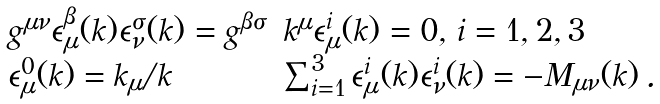<formula> <loc_0><loc_0><loc_500><loc_500>\begin{array} { l l } g ^ { \mu \nu } \epsilon _ { \mu } ^ { \beta } ( k ) \epsilon _ { \nu } ^ { \sigma } ( k ) = g ^ { \beta \sigma } & k ^ { \mu } \epsilon _ { \mu } ^ { i } ( k ) = 0 , \, i = 1 , 2 , 3 \\ \epsilon _ { \mu } ^ { 0 } ( k ) = k _ { \mu } / k & \sum _ { i = 1 } ^ { 3 } \epsilon _ { \mu } ^ { i } ( k ) \epsilon _ { \nu } ^ { i } ( k ) = - M _ { \mu \nu } ( k ) \, . \end{array}</formula> 